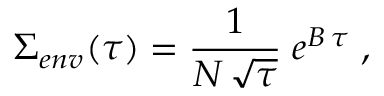<formula> <loc_0><loc_0><loc_500><loc_500>\Sigma _ { e n v } ( \tau ) = { \frac { 1 } { N \, \sqrt { \tau } } } \, e ^ { B \, \tau } \, ,</formula> 